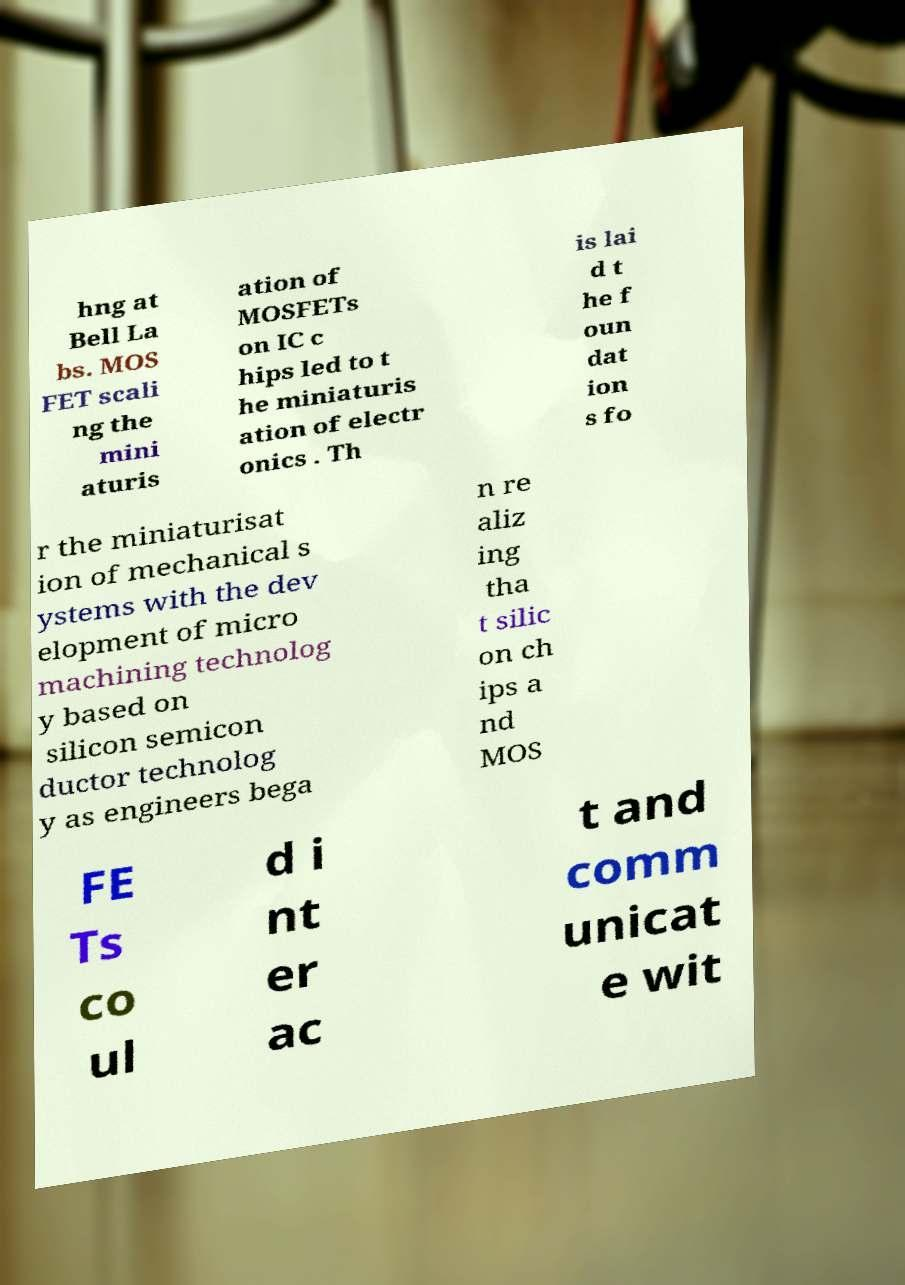What messages or text are displayed in this image? I need them in a readable, typed format. hng at Bell La bs. MOS FET scali ng the mini aturis ation of MOSFETs on IC c hips led to t he miniaturis ation of electr onics . Th is lai d t he f oun dat ion s fo r the miniaturisat ion of mechanical s ystems with the dev elopment of micro machining technolog y based on silicon semicon ductor technolog y as engineers bega n re aliz ing tha t silic on ch ips a nd MOS FE Ts co ul d i nt er ac t and comm unicat e wit 